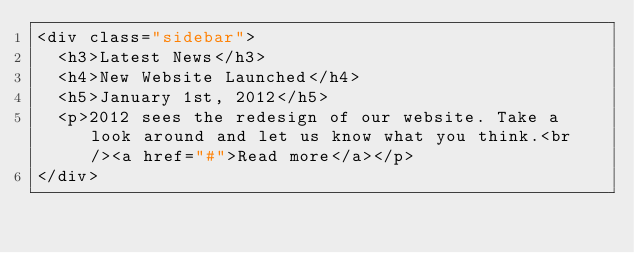<code> <loc_0><loc_0><loc_500><loc_500><_PHP_><div class="sidebar">
	<h3>Latest News</h3>
	<h4>New Website Launched</h4>
	<h5>January 1st, 2012</h5>
	<p>2012 sees the redesign of our website. Take a look around and let us know what you think.<br /><a href="#">Read more</a></p>
</div></code> 